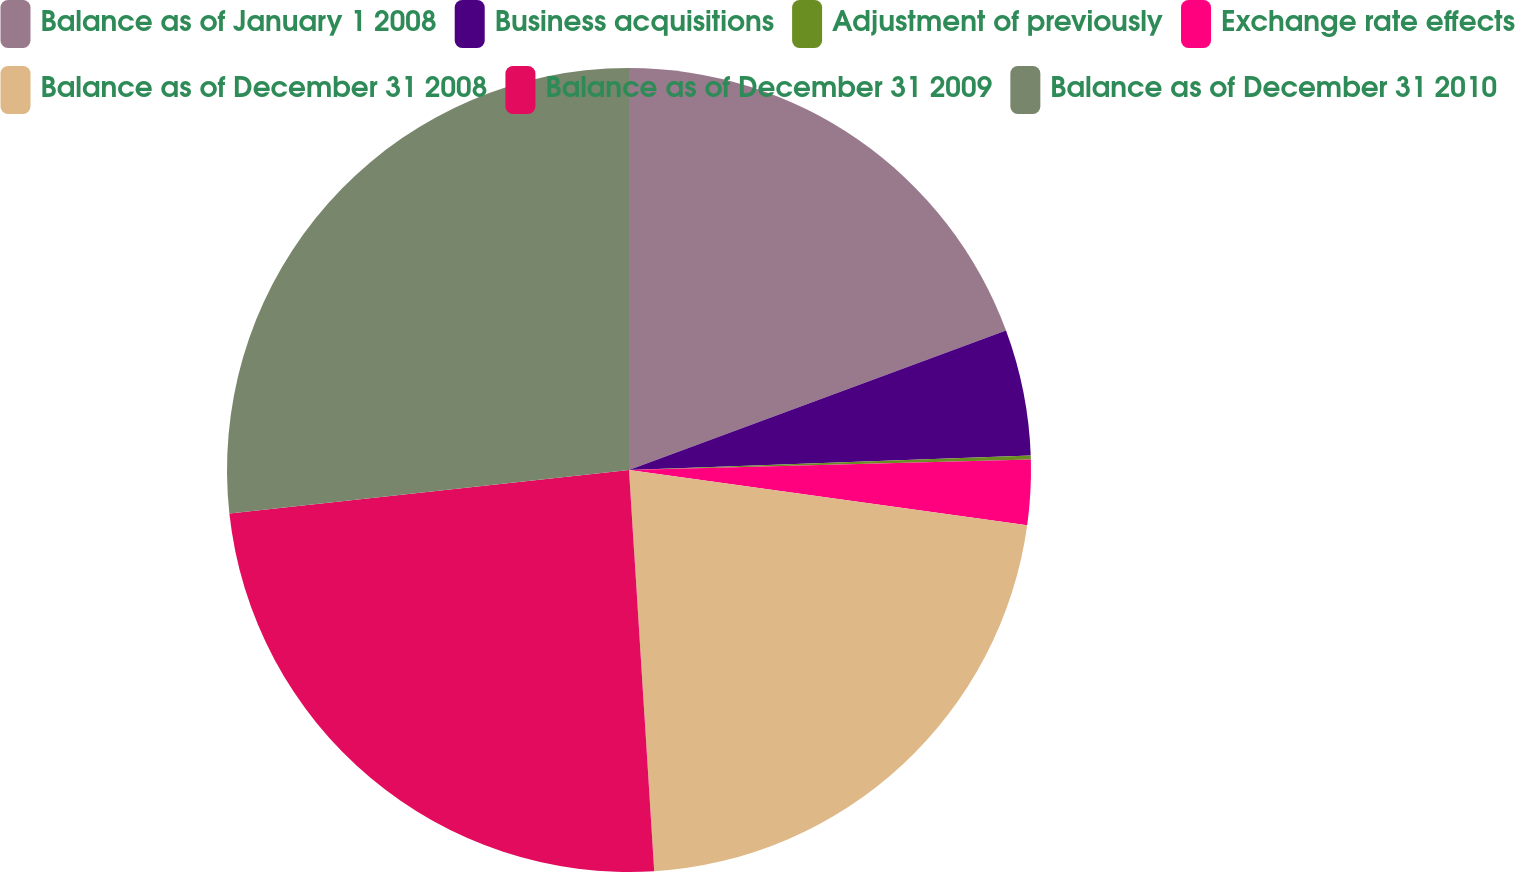Convert chart. <chart><loc_0><loc_0><loc_500><loc_500><pie_chart><fcel>Balance as of January 1 2008<fcel>Business acquisitions<fcel>Adjustment of previously<fcel>Exchange rate effects<fcel>Balance as of December 31 2008<fcel>Balance as of December 31 2009<fcel>Balance as of December 31 2010<nl><fcel>19.36%<fcel>5.07%<fcel>0.15%<fcel>2.61%<fcel>21.81%<fcel>24.27%<fcel>26.73%<nl></chart> 